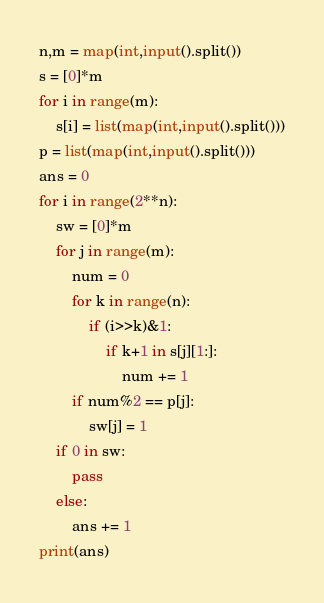Convert code to text. <code><loc_0><loc_0><loc_500><loc_500><_Python_>n,m = map(int,input().split())
s = [0]*m
for i in range(m):
    s[i] = list(map(int,input().split()))
p = list(map(int,input().split()))
ans = 0
for i in range(2**n):
    sw = [0]*m
    for j in range(m):
        num = 0
        for k in range(n):
            if (i>>k)&1:
                if k+1 in s[j][1:]:
                    num += 1
        if num%2 == p[j]:
            sw[j] = 1
    if 0 in sw:
        pass
    else:
        ans += 1
print(ans)
</code> 